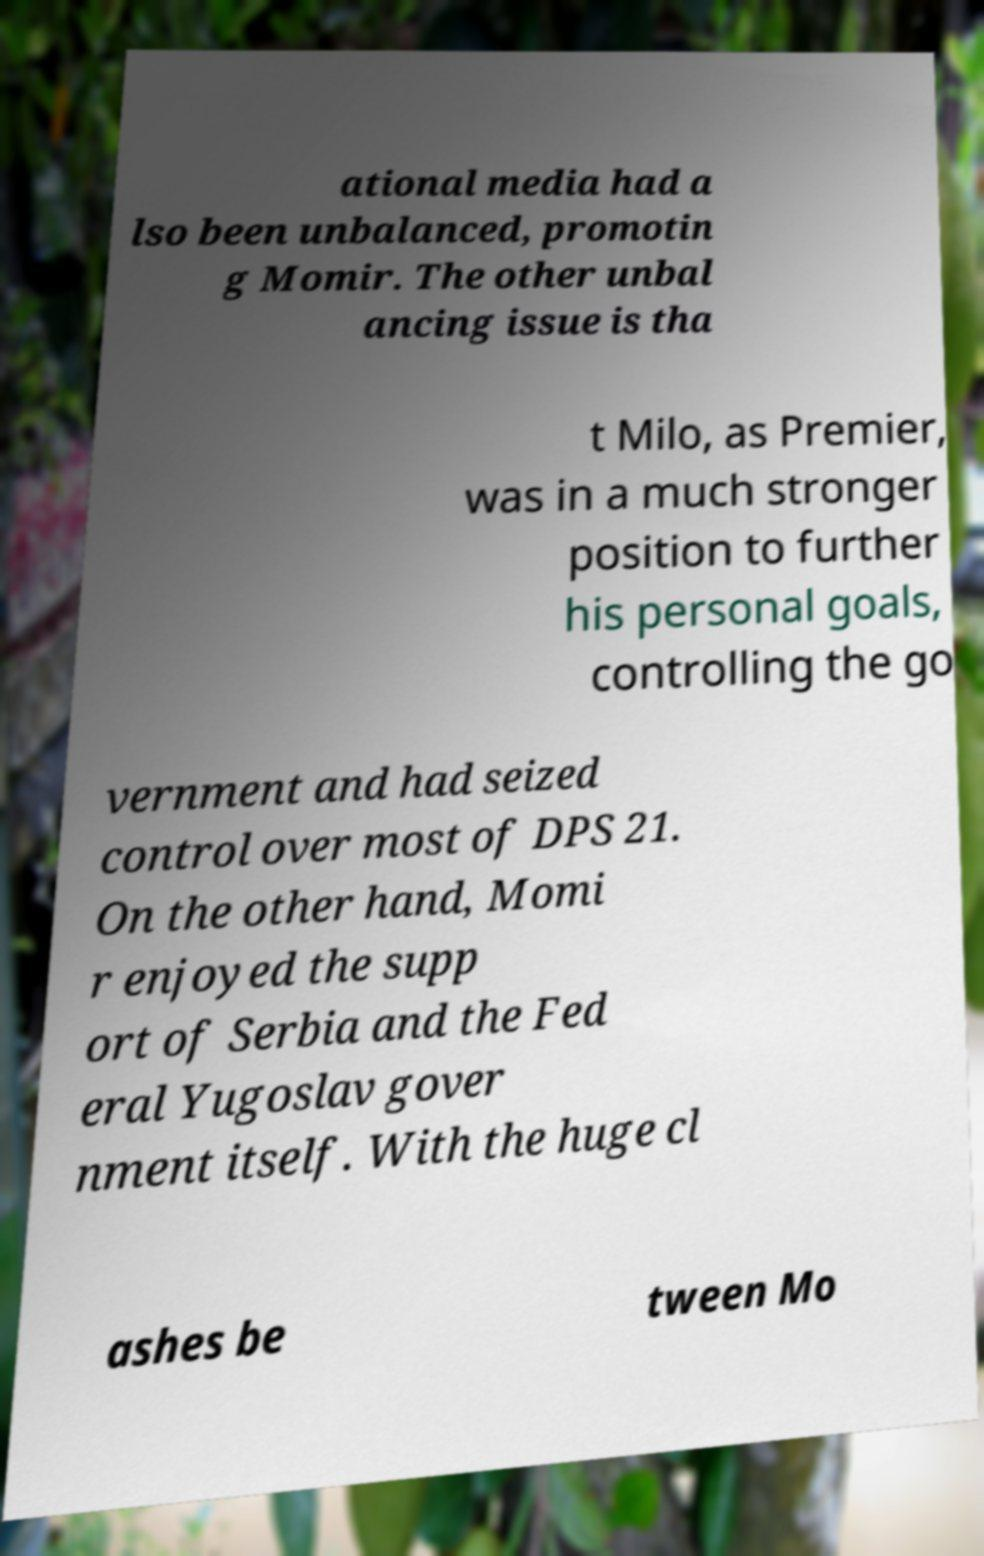Can you read and provide the text displayed in the image?This photo seems to have some interesting text. Can you extract and type it out for me? ational media had a lso been unbalanced, promotin g Momir. The other unbal ancing issue is tha t Milo, as Premier, was in a much stronger position to further his personal goals, controlling the go vernment and had seized control over most of DPS 21. On the other hand, Momi r enjoyed the supp ort of Serbia and the Fed eral Yugoslav gover nment itself. With the huge cl ashes be tween Mo 